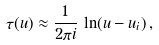Convert formula to latex. <formula><loc_0><loc_0><loc_500><loc_500>\tau ( u ) \approx \frac { 1 } { 2 \pi i } \, \ln ( u - u _ { i } ) \, ,</formula> 